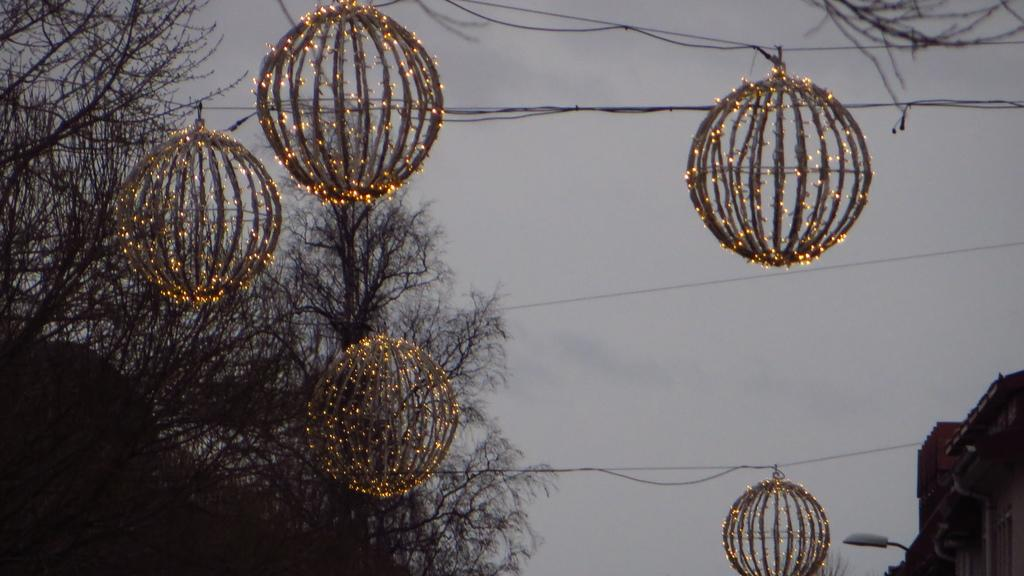What objects are in the foreground of the image? There are lanterns and wires in the foreground of the image. What can be seen in the background of the image? There are trees, houses, a pole, and the sky visible in the background of the image. How many different types of structures are present in the background? There are two types of structures in the background: houses and a pole. What type of gold jewelry can be seen hanging from the trees in the image? There is no gold jewelry present in the image; the trees are not adorned with any such items. How many frogs can be seen hopping around the lanterns in the image? There are no frogs visible in the image; the focus is on the lanterns and wires in the foreground. 